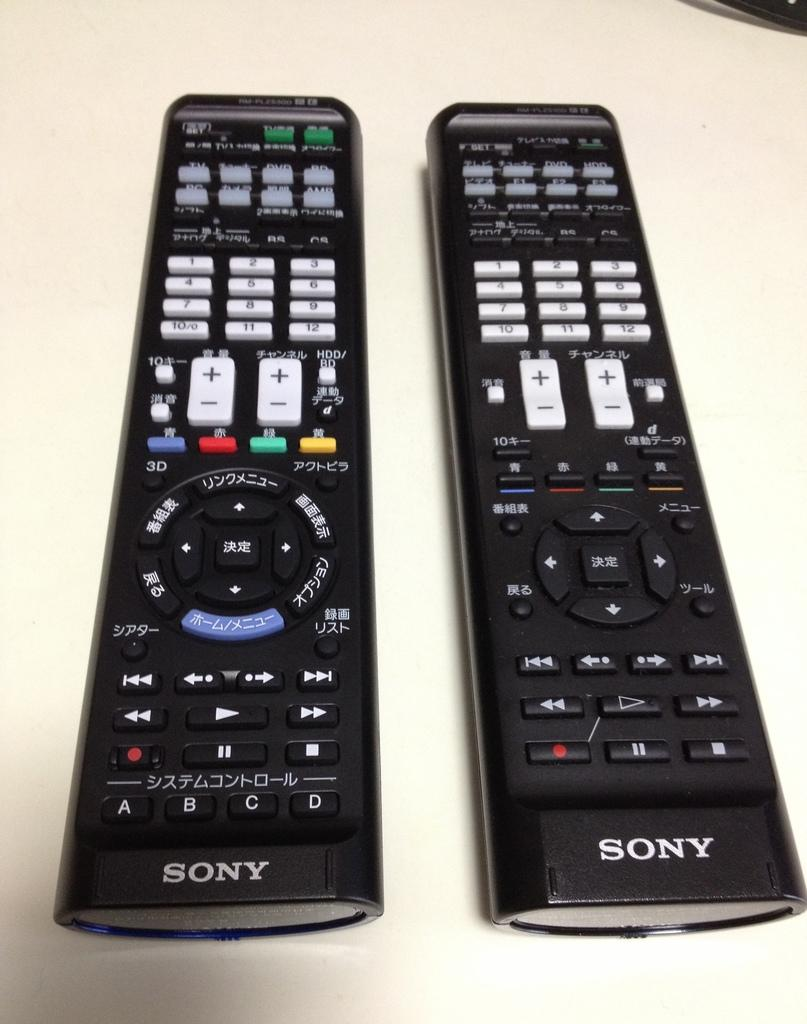<image>
Present a compact description of the photo's key features. Two black sony brand remotes sitting side by side on a white formica table. 